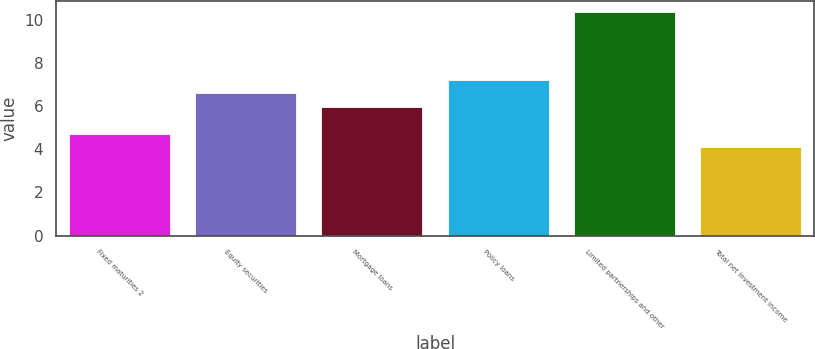Convert chart. <chart><loc_0><loc_0><loc_500><loc_500><bar_chart><fcel>Fixed maturities 2<fcel>Equity securities<fcel>Mortgage loans<fcel>Policy loans<fcel>Limited partnerships and other<fcel>Total net investment income<nl><fcel>4.73<fcel>6.62<fcel>5.99<fcel>7.25<fcel>10.4<fcel>4.1<nl></chart> 